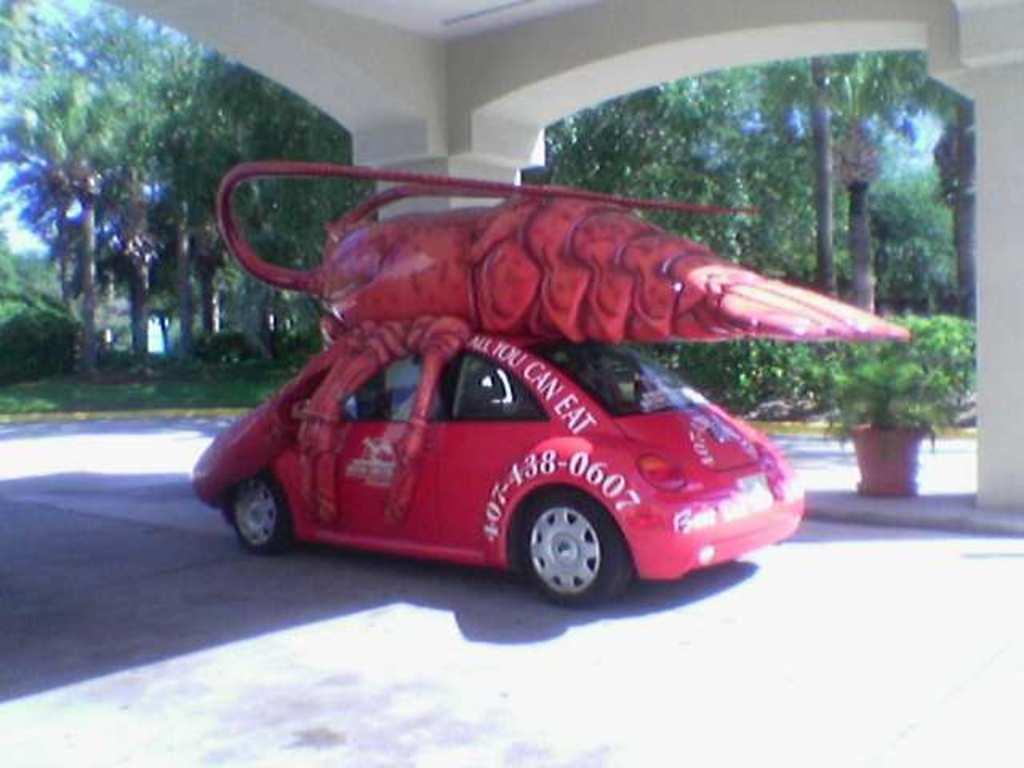Please provide a concise description of this image. In this image I can see the car and I can see the statue of an insect on the car. To the side I can see the flower pot and the pillars. In the background there are many trees and the sky. 